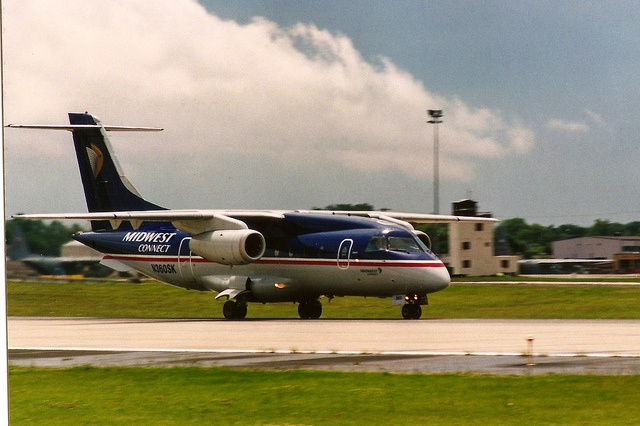Describe the objects in this image and their specific colors. I can see a airplane in brown, black, gray, darkgreen, and lightgray tones in this image. 